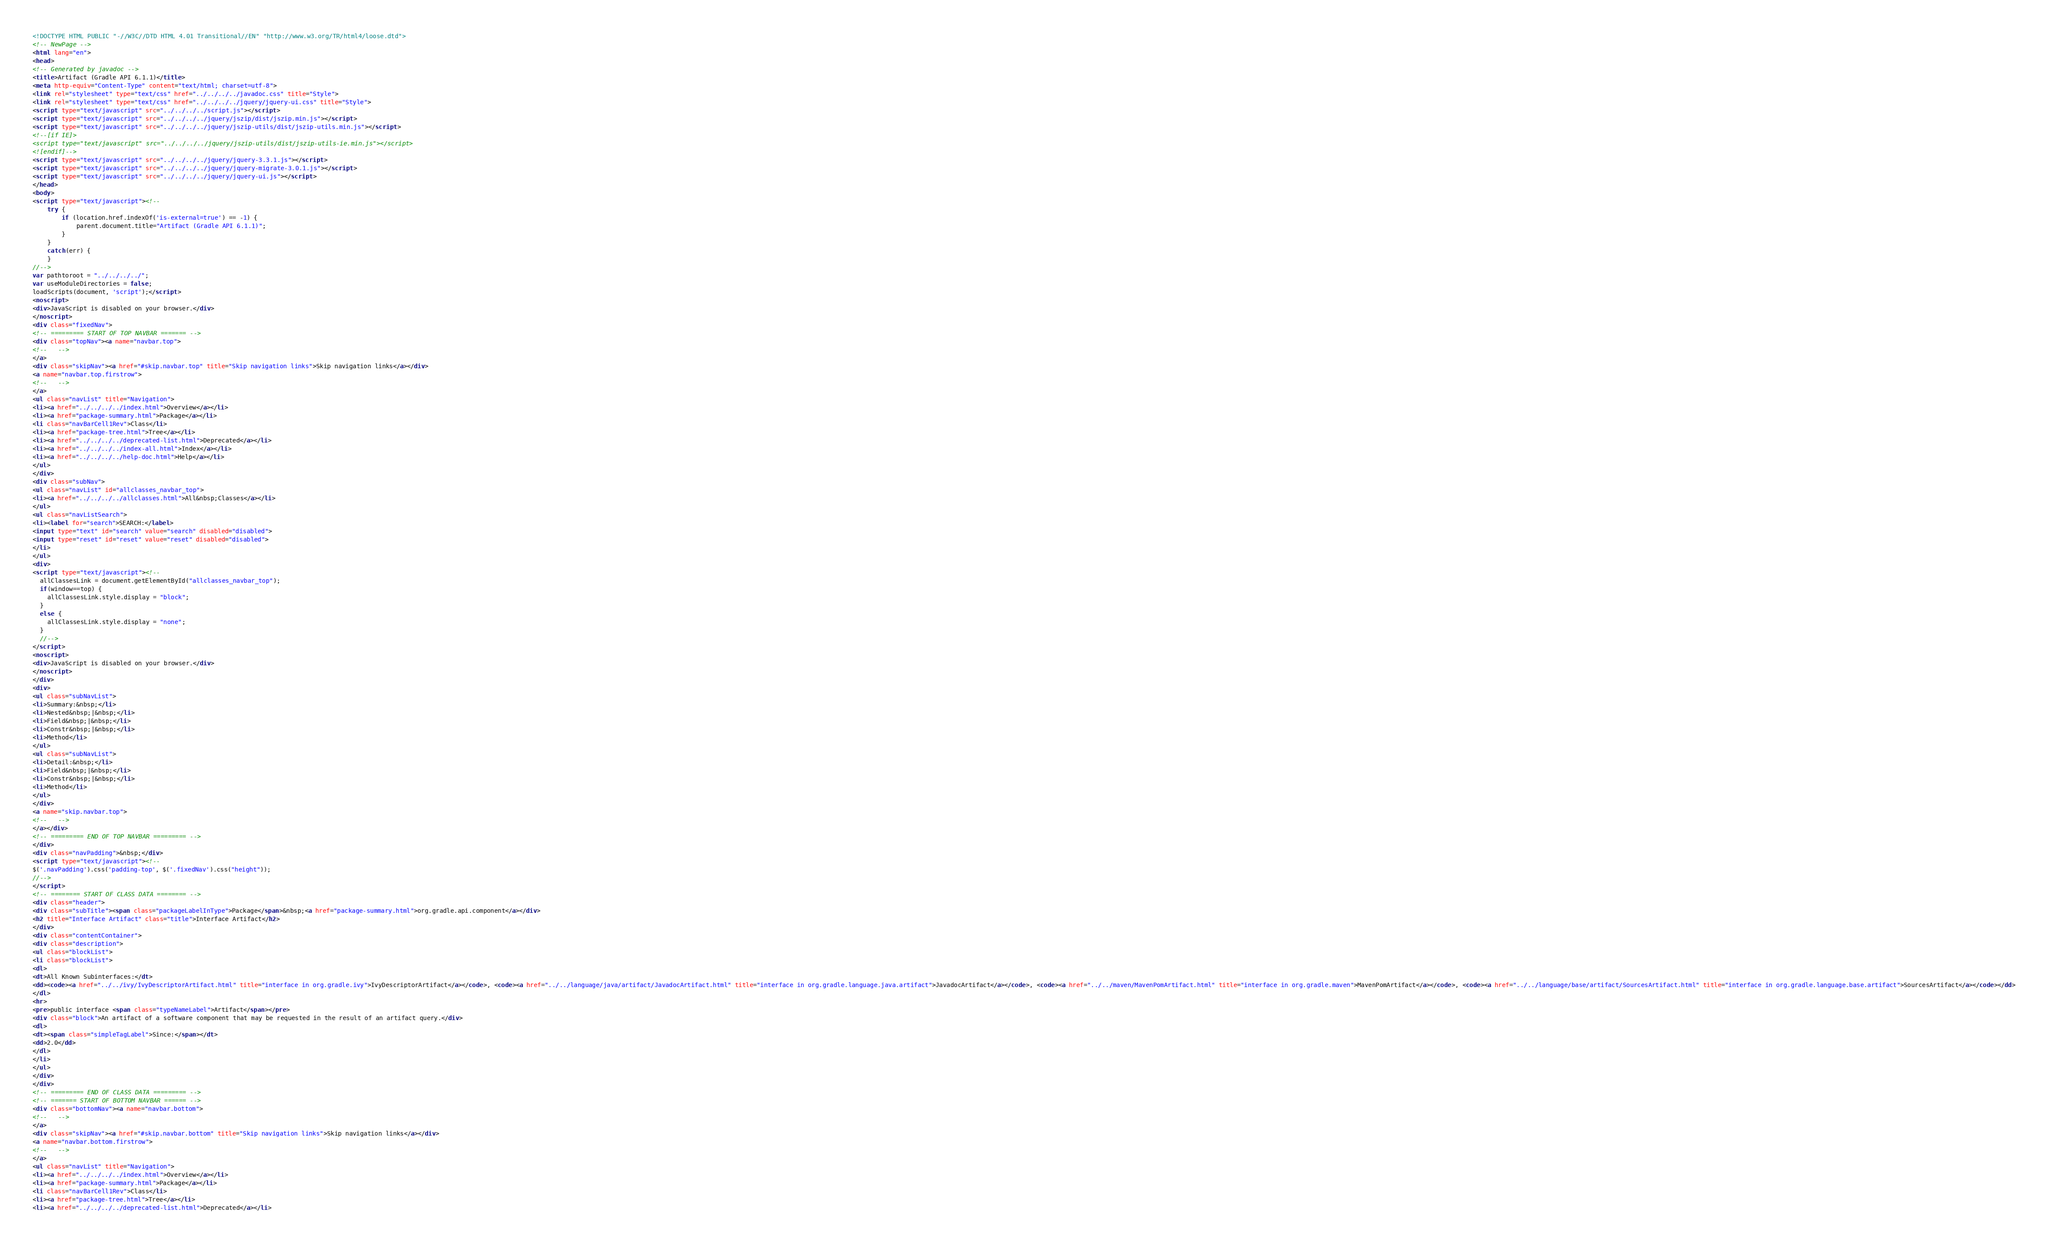<code> <loc_0><loc_0><loc_500><loc_500><_HTML_><!DOCTYPE HTML PUBLIC "-//W3C//DTD HTML 4.01 Transitional//EN" "http://www.w3.org/TR/html4/loose.dtd">
<!-- NewPage -->
<html lang="en">
<head>
<!-- Generated by javadoc -->
<title>Artifact (Gradle API 6.1.1)</title>
<meta http-equiv="Content-Type" content="text/html; charset=utf-8">
<link rel="stylesheet" type="text/css" href="../../../../javadoc.css" title="Style">
<link rel="stylesheet" type="text/css" href="../../../../jquery/jquery-ui.css" title="Style">
<script type="text/javascript" src="../../../../script.js"></script>
<script type="text/javascript" src="../../../../jquery/jszip/dist/jszip.min.js"></script>
<script type="text/javascript" src="../../../../jquery/jszip-utils/dist/jszip-utils.min.js"></script>
<!--[if IE]>
<script type="text/javascript" src="../../../../jquery/jszip-utils/dist/jszip-utils-ie.min.js"></script>
<![endif]-->
<script type="text/javascript" src="../../../../jquery/jquery-3.3.1.js"></script>
<script type="text/javascript" src="../../../../jquery/jquery-migrate-3.0.1.js"></script>
<script type="text/javascript" src="../../../../jquery/jquery-ui.js"></script>
</head>
<body>
<script type="text/javascript"><!--
    try {
        if (location.href.indexOf('is-external=true') == -1) {
            parent.document.title="Artifact (Gradle API 6.1.1)";
        }
    }
    catch(err) {
    }
//-->
var pathtoroot = "../../../../";
var useModuleDirectories = false;
loadScripts(document, 'script');</script>
<noscript>
<div>JavaScript is disabled on your browser.</div>
</noscript>
<div class="fixedNav">
<!-- ========= START OF TOP NAVBAR ======= -->
<div class="topNav"><a name="navbar.top">
<!--   -->
</a>
<div class="skipNav"><a href="#skip.navbar.top" title="Skip navigation links">Skip navigation links</a></div>
<a name="navbar.top.firstrow">
<!--   -->
</a>
<ul class="navList" title="Navigation">
<li><a href="../../../../index.html">Overview</a></li>
<li><a href="package-summary.html">Package</a></li>
<li class="navBarCell1Rev">Class</li>
<li><a href="package-tree.html">Tree</a></li>
<li><a href="../../../../deprecated-list.html">Deprecated</a></li>
<li><a href="../../../../index-all.html">Index</a></li>
<li><a href="../../../../help-doc.html">Help</a></li>
</ul>
</div>
<div class="subNav">
<ul class="navList" id="allclasses_navbar_top">
<li><a href="../../../../allclasses.html">All&nbsp;Classes</a></li>
</ul>
<ul class="navListSearch">
<li><label for="search">SEARCH:</label>
<input type="text" id="search" value="search" disabled="disabled">
<input type="reset" id="reset" value="reset" disabled="disabled">
</li>
</ul>
<div>
<script type="text/javascript"><!--
  allClassesLink = document.getElementById("allclasses_navbar_top");
  if(window==top) {
    allClassesLink.style.display = "block";
  }
  else {
    allClassesLink.style.display = "none";
  }
  //-->
</script>
<noscript>
<div>JavaScript is disabled on your browser.</div>
</noscript>
</div>
<div>
<ul class="subNavList">
<li>Summary:&nbsp;</li>
<li>Nested&nbsp;|&nbsp;</li>
<li>Field&nbsp;|&nbsp;</li>
<li>Constr&nbsp;|&nbsp;</li>
<li>Method</li>
</ul>
<ul class="subNavList">
<li>Detail:&nbsp;</li>
<li>Field&nbsp;|&nbsp;</li>
<li>Constr&nbsp;|&nbsp;</li>
<li>Method</li>
</ul>
</div>
<a name="skip.navbar.top">
<!--   -->
</a></div>
<!-- ========= END OF TOP NAVBAR ========= -->
</div>
<div class="navPadding">&nbsp;</div>
<script type="text/javascript"><!--
$('.navPadding').css('padding-top', $('.fixedNav').css("height"));
//-->
</script>
<!-- ======== START OF CLASS DATA ======== -->
<div class="header">
<div class="subTitle"><span class="packageLabelInType">Package</span>&nbsp;<a href="package-summary.html">org.gradle.api.component</a></div>
<h2 title="Interface Artifact" class="title">Interface Artifact</h2>
</div>
<div class="contentContainer">
<div class="description">
<ul class="blockList">
<li class="blockList">
<dl>
<dt>All Known Subinterfaces:</dt>
<dd><code><a href="../../ivy/IvyDescriptorArtifact.html" title="interface in org.gradle.ivy">IvyDescriptorArtifact</a></code>, <code><a href="../../language/java/artifact/JavadocArtifact.html" title="interface in org.gradle.language.java.artifact">JavadocArtifact</a></code>, <code><a href="../../maven/MavenPomArtifact.html" title="interface in org.gradle.maven">MavenPomArtifact</a></code>, <code><a href="../../language/base/artifact/SourcesArtifact.html" title="interface in org.gradle.language.base.artifact">SourcesArtifact</a></code></dd>
</dl>
<hr>
<pre>public interface <span class="typeNameLabel">Artifact</span></pre>
<div class="block">An artifact of a software component that may be requested in the result of an artifact query.</div>
<dl>
<dt><span class="simpleTagLabel">Since:</span></dt>
<dd>2.0</dd>
</dl>
</li>
</ul>
</div>
</div>
<!-- ========= END OF CLASS DATA ========= -->
<!-- ======= START OF BOTTOM NAVBAR ====== -->
<div class="bottomNav"><a name="navbar.bottom">
<!--   -->
</a>
<div class="skipNav"><a href="#skip.navbar.bottom" title="Skip navigation links">Skip navigation links</a></div>
<a name="navbar.bottom.firstrow">
<!--   -->
</a>
<ul class="navList" title="Navigation">
<li><a href="../../../../index.html">Overview</a></li>
<li><a href="package-summary.html">Package</a></li>
<li class="navBarCell1Rev">Class</li>
<li><a href="package-tree.html">Tree</a></li>
<li><a href="../../../../deprecated-list.html">Deprecated</a></li></code> 